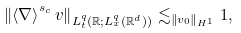Convert formula to latex. <formula><loc_0><loc_0><loc_500><loc_500>\left \| \left \langle \nabla \right \rangle ^ { s _ { c } } v \right \| _ { L _ { t } ^ { q } \left ( \mathbb { R } ; L _ { x } ^ { q } ( \mathbb { R } ^ { d } ) \right ) } \lesssim _ { \left \| v _ { 0 } \right \| _ { H ^ { 1 } } } 1 ,</formula> 